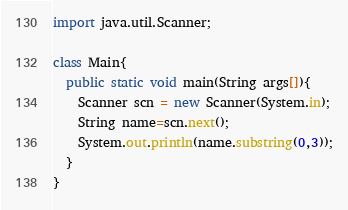Convert code to text. <code><loc_0><loc_0><loc_500><loc_500><_Java_>import java.util.Scanner;

class Main{
  public static void main(String args[]){
    Scanner scn = new Scanner(System.in);
    String name=scn.next();
    System.out.println(name.substring(0,3));
  }
}</code> 